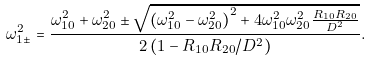Convert formula to latex. <formula><loc_0><loc_0><loc_500><loc_500>\omega _ { 1 \pm } ^ { 2 } = \frac { { \omega _ { 1 0 } ^ { 2 } + \omega _ { 2 0 } ^ { 2 } \pm \sqrt { \left ( { \omega _ { 1 0 } ^ { 2 } - \omega _ { 2 0 } ^ { 2 } } \right ) ^ { 2 } + 4 \omega _ { 1 0 } ^ { 2 } \omega _ { 2 0 } ^ { 2 } \frac { { R _ { 1 0 } R _ { 2 0 } } } { D ^ { 2 } } } } } { { 2 \left ( { 1 - R _ { 1 0 } R _ { 2 0 } / D ^ { 2 } } \right ) } } .</formula> 